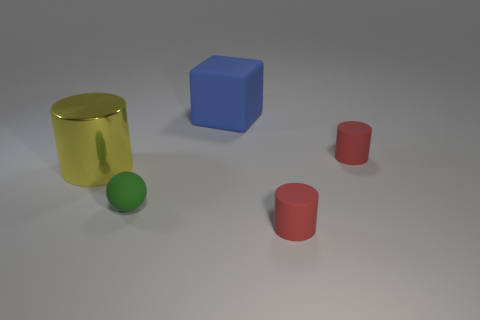If these objects were part of a children's game, how might that game be played? If these objects were part of a children's game, it might be a sorting or matching game where players must group objects by similar attributes such as color or shape. For instance, it could involve matching similar colors or finding objects with the same shape, encouraging children to observe and classify the objects based on their physical characteristics. 